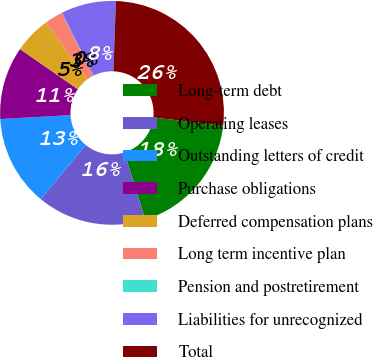Convert chart. <chart><loc_0><loc_0><loc_500><loc_500><pie_chart><fcel>Long-term debt<fcel>Operating leases<fcel>Outstanding letters of credit<fcel>Purchase obligations<fcel>Deferred compensation plans<fcel>Long term incentive plan<fcel>Pension and postretirement<fcel>Liabilities for unrecognized<fcel>Total<nl><fcel>18.39%<fcel>15.77%<fcel>13.15%<fcel>10.53%<fcel>5.29%<fcel>2.67%<fcel>0.04%<fcel>7.91%<fcel>26.26%<nl></chart> 